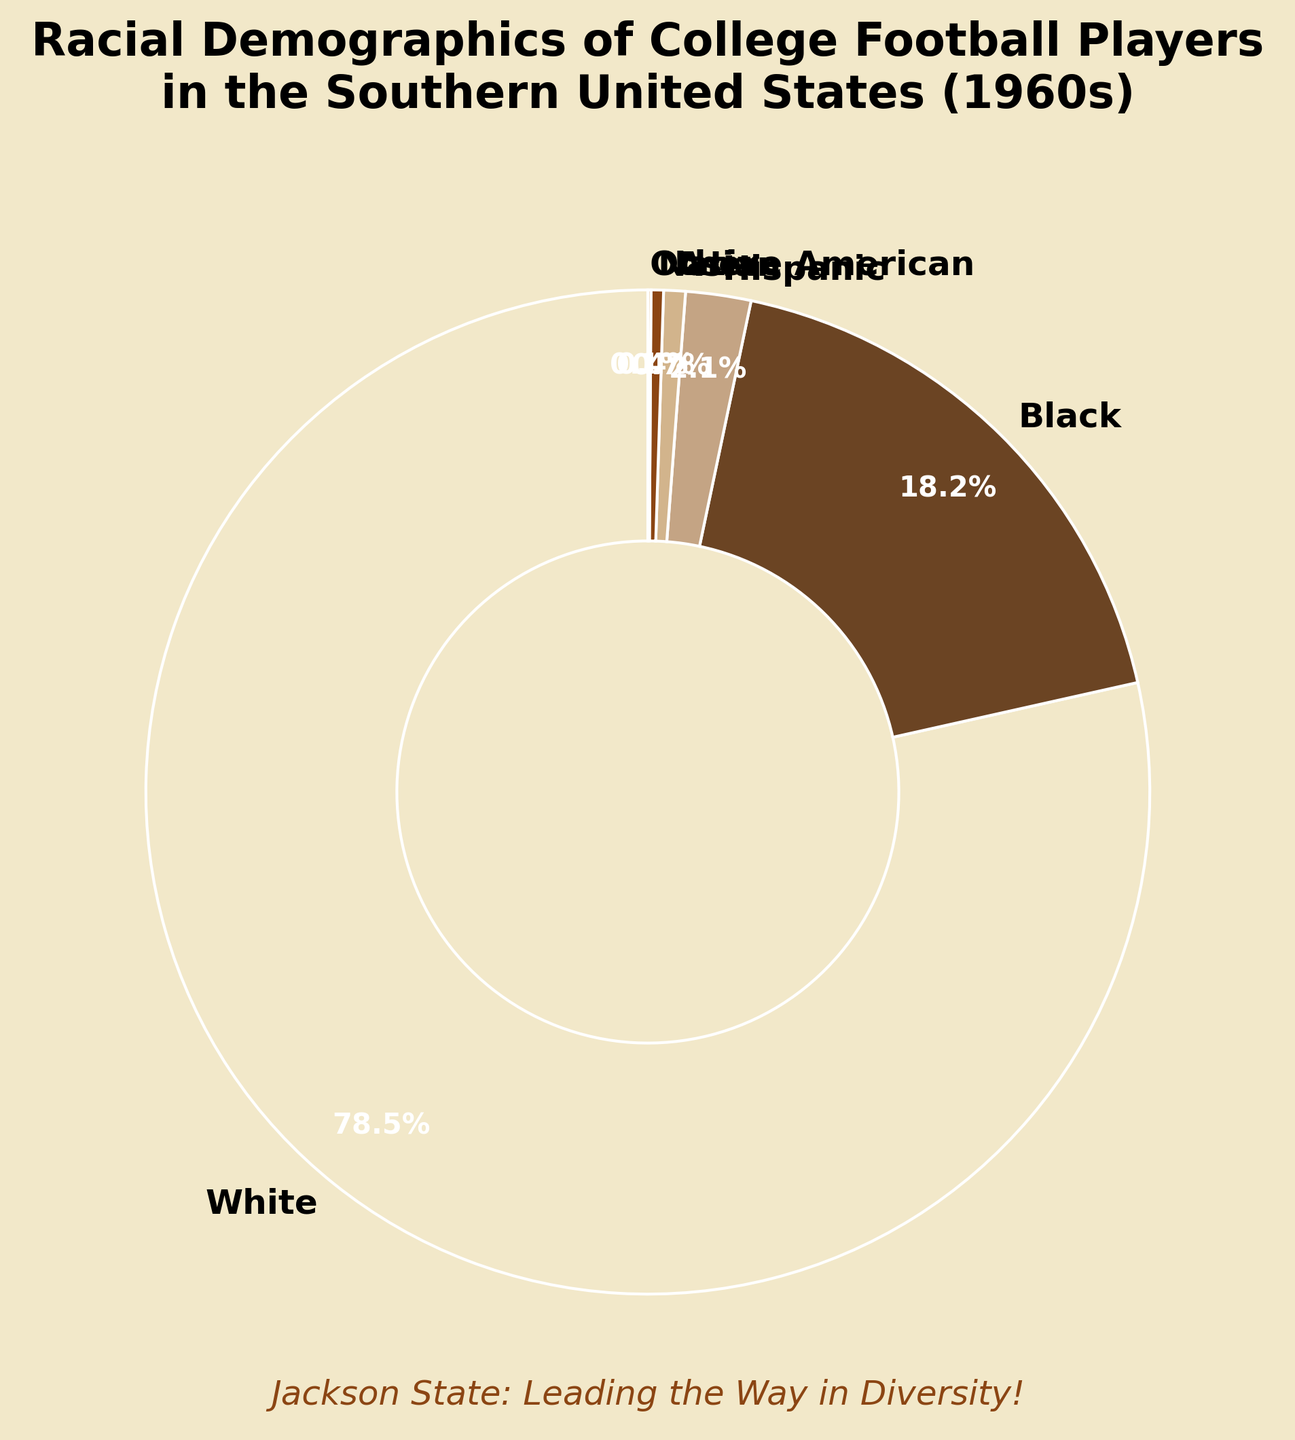What is the most represented racial group in the pie chart? The most represented group is the one with the largest percentage. Looking at the chart, the "White" group has the largest section with 78.5%.
Answer: White Which racial group has the second-largest representation? Identify the group with the second-largest section after the largest. The "Black" group, with 18.2%, has the second-largest representation.
Answer: Black How much larger is the percentage of White players compared to Black players? Subtract the percentage of Black players from that of White players: 78.5% - 18.2% = 60.3%.
Answer: 60.3% If you combined the percentages of Hispanics, Asians, Native Americans, and those labeled "Other," would their total exceed the percentage of Black players? Add the percentages of Hispanic (2.1%), Asian (0.7%), Native American (0.4%), and Other (0.1%) and compare to that of Black players. 2.1% + 0.7% + 0.4% + 0.1% = 3.3%, which is less than 18.2%.
Answer: No How does the percentage of Hispanic players compare to the percentage of Asian players? Compare the values of Hispanic (2.1%) and Asian (0.7%) players. The percentage of Hispanic players is greater.
Answer: Greater What is the total percentage shared by non-White racial groups? Sum the percentages of Black (18.2%), Hispanic (2.1%), Asian (0.7%), Native American (0.4%), and Other (0.1%) players. 18.2% + 2.1% + 0.7% + 0.4% + 0.1% = 21.5%.
Answer: 21.5% Which racial group has the smallest representation, and what is its percentage? Identify the group with the smallest section. "Other" has the smallest representation with 0.1%.
Answer: Other, 0.1% If the total number of players is 1000, how many players belong to the Black racial group? Multiply the total number of players by the percentage of Black players: 1000 * 18.2% = 182 players.
Answer: 182 What visual feature is used to emphasize Jackson State and its role in diversity? Look for any text or visual elements distinct from the pie chart. The title mentions "Jackson State: Leading the Way in Diversity!"
Answer: A subtitle Which color corresponds to the slice representing Hispanic players, and where is it located? Identify the color for "Hispanic" in the legend or by observing the pie chart directly. The "Hispanic" slice is a lighter brown, located near the bottom of the chart.
Answer: Lighter brown, bottom 